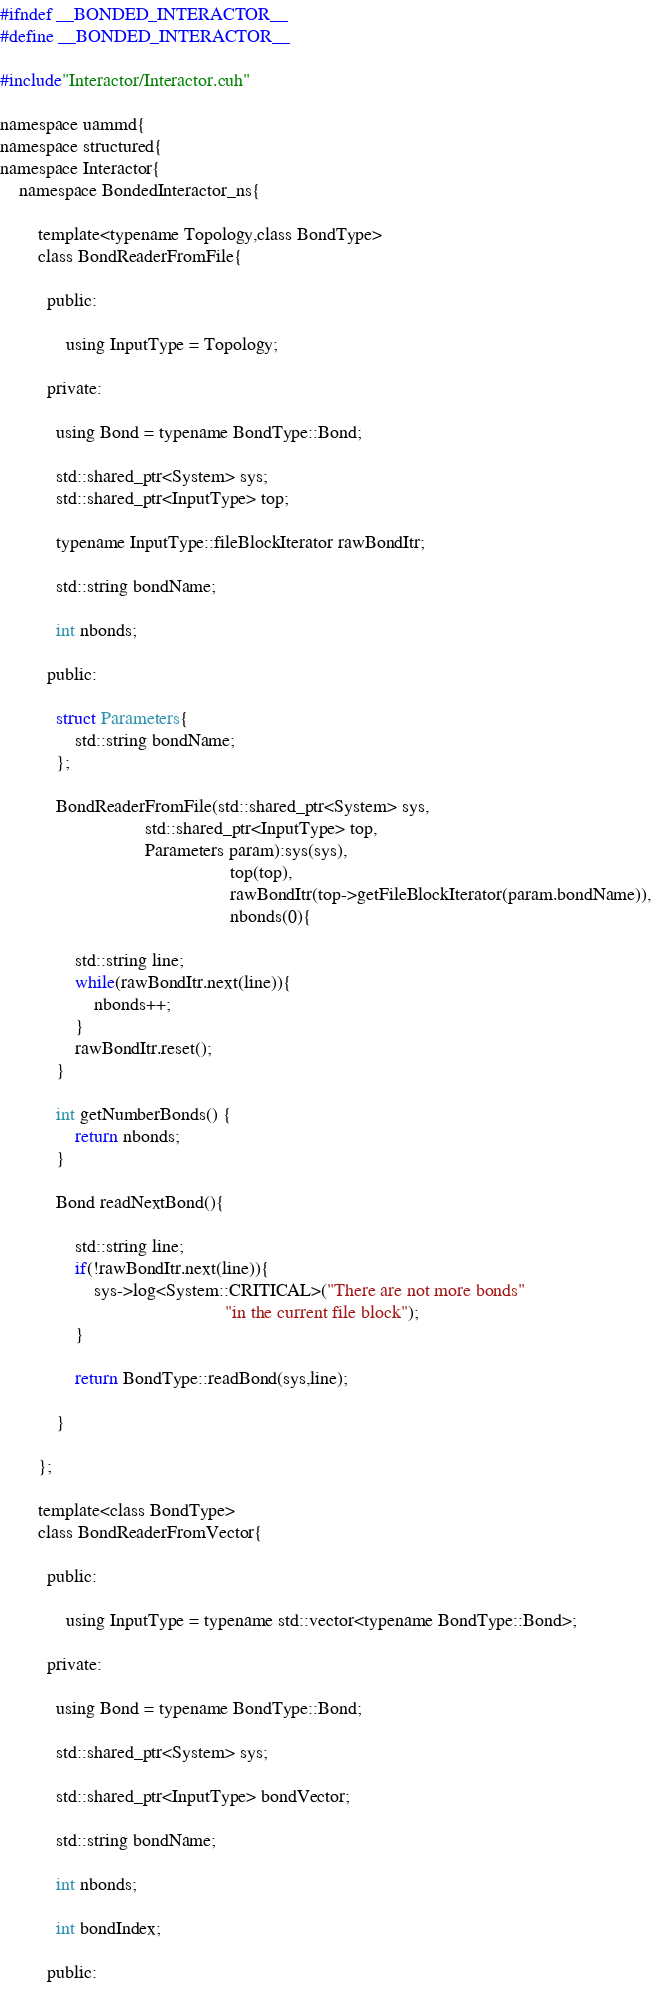<code> <loc_0><loc_0><loc_500><loc_500><_Cuda_>#ifndef __BONDED_INTERACTOR__
#define __BONDED_INTERACTOR__

#include"Interactor/Interactor.cuh"

namespace uammd{
namespace structured{
namespace Interactor{
    namespace BondedInteractor_ns{

        template<typename Topology,class BondType>
        class BondReaderFromFile{

          public:

              using InputType = Topology;
          
          private:

            using Bond = typename BondType::Bond;
            
            std::shared_ptr<System> sys;
            std::shared_ptr<InputType> top;

            typename InputType::fileBlockIterator rawBondItr;

            std::string bondName;
            
            int nbonds;
        
          public:
        
            struct Parameters{
                std::string bondName;
            };
        
            BondReaderFromFile(std::shared_ptr<System> sys,
                               std::shared_ptr<InputType> top,
                               Parameters param):sys(sys),
                                                 top(top),
                                                 rawBondItr(top->getFileBlockIterator(param.bondName)),
                                                 nbonds(0){
                
                std::string line;
                while(rawBondItr.next(line)){
                    nbonds++;
                }
                rawBondItr.reset();
            }
        
            int getNumberBonds() {
                return nbonds;
            }
        
            Bond readNextBond(){
                
                std::string line;
                if(!rawBondItr.next(line)){
                    sys->log<System::CRITICAL>("There are not more bonds"
                                                "in the current file block");
                }
        
                return BondType::readBond(sys,line);
        
            }
        
        };
        
        template<class BondType>
        class BondReaderFromVector{
          
          public:

              using InputType = typename std::vector<typename BondType::Bond>;
          
          private:

            using Bond = typename BondType::Bond;
            
            std::shared_ptr<System> sys;

            std::shared_ptr<InputType> bondVector;

            std::string bondName;
            
            int nbonds;

            int bondIndex;
        
          public:
        </code> 